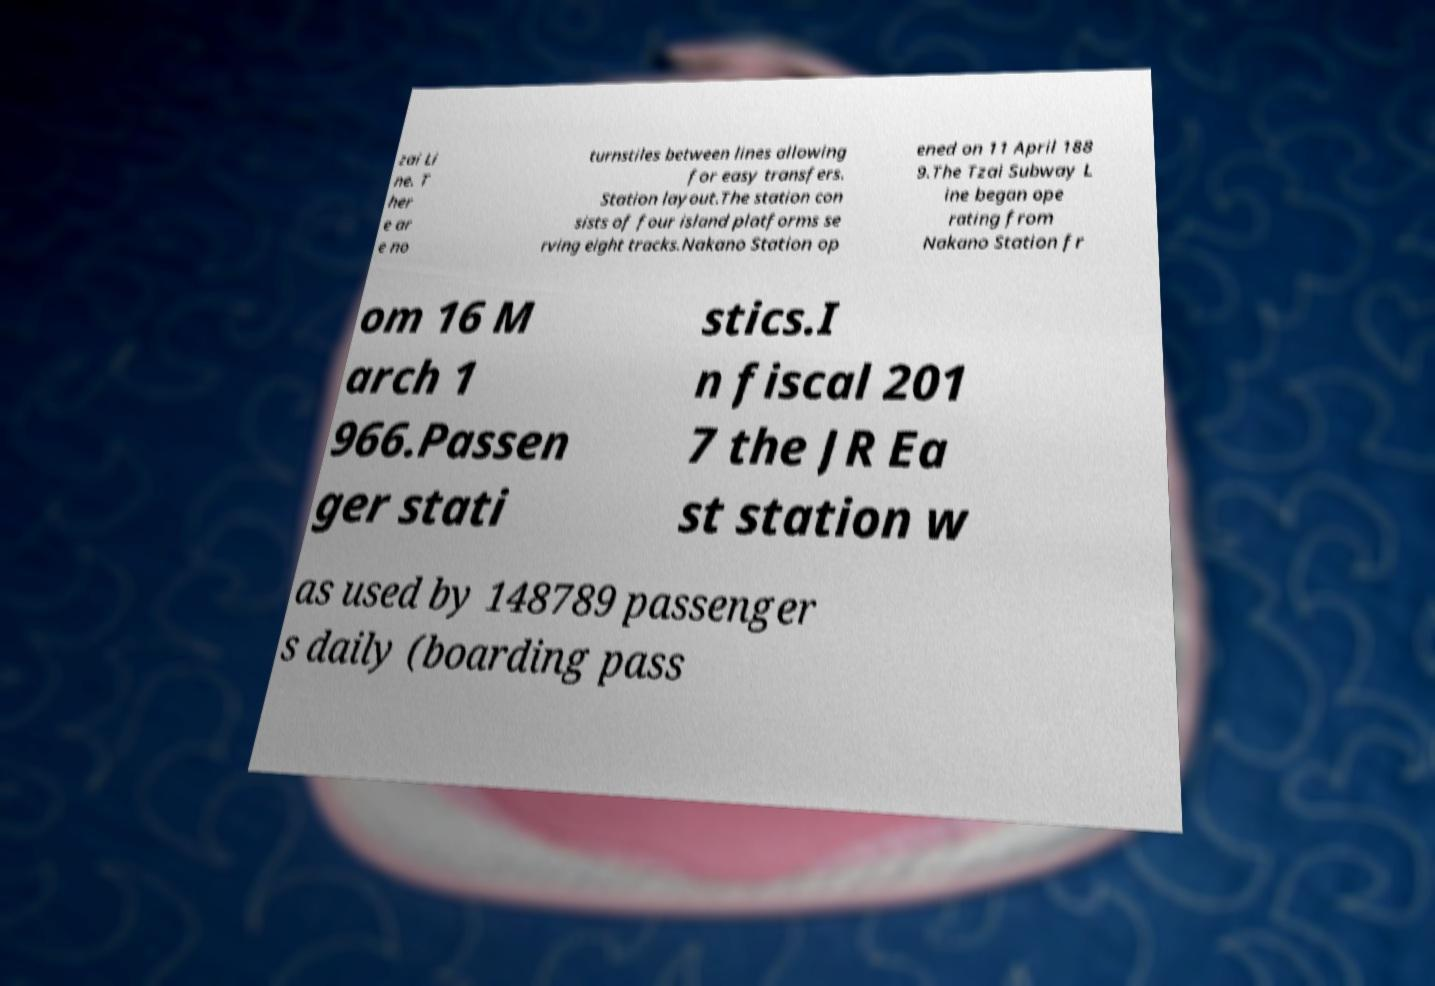There's text embedded in this image that I need extracted. Can you transcribe it verbatim? zai Li ne. T her e ar e no turnstiles between lines allowing for easy transfers. Station layout.The station con sists of four island platforms se rving eight tracks.Nakano Station op ened on 11 April 188 9.The Tzai Subway L ine began ope rating from Nakano Station fr om 16 M arch 1 966.Passen ger stati stics.I n fiscal 201 7 the JR Ea st station w as used by 148789 passenger s daily (boarding pass 